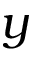Convert formula to latex. <formula><loc_0><loc_0><loc_500><loc_500>y</formula> 